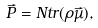<formula> <loc_0><loc_0><loc_500><loc_500>\vec { P } = N t r ( \rho \vec { \mu } ) ,</formula> 